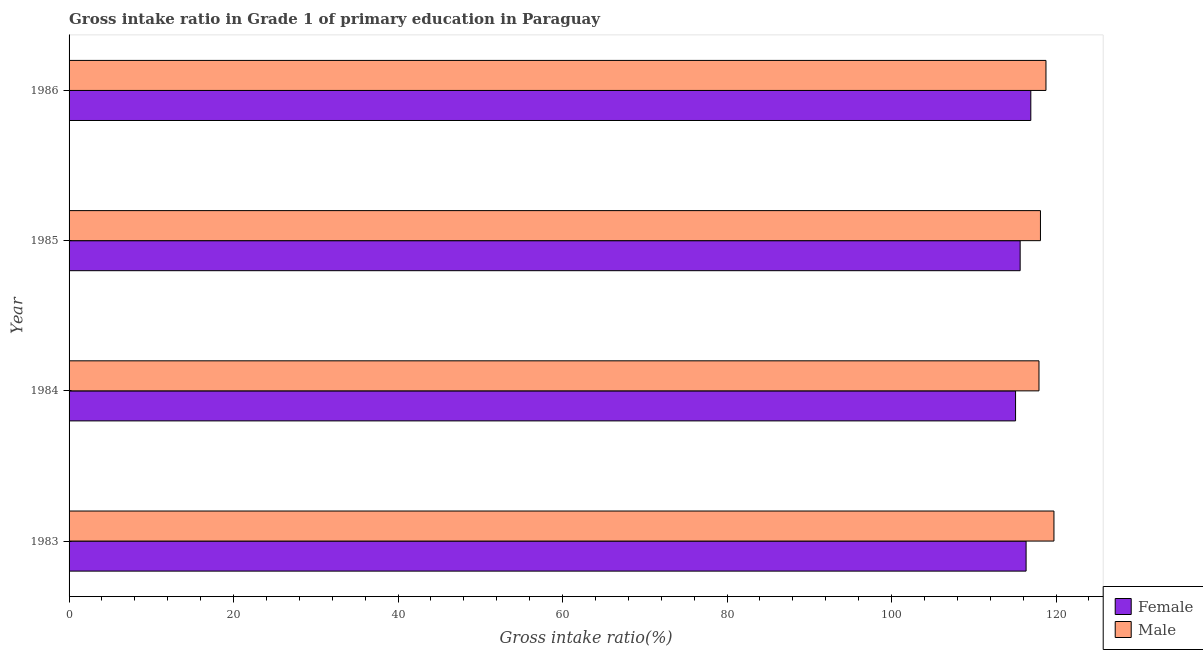How many groups of bars are there?
Provide a succinct answer. 4. Are the number of bars per tick equal to the number of legend labels?
Provide a short and direct response. Yes. How many bars are there on the 4th tick from the top?
Your answer should be very brief. 2. How many bars are there on the 1st tick from the bottom?
Your answer should be very brief. 2. What is the label of the 2nd group of bars from the top?
Keep it short and to the point. 1985. What is the gross intake ratio(female) in 1983?
Offer a terse response. 116.36. Across all years, what is the maximum gross intake ratio(male)?
Provide a succinct answer. 119.75. Across all years, what is the minimum gross intake ratio(female)?
Your response must be concise. 115.08. In which year was the gross intake ratio(female) maximum?
Keep it short and to the point. 1986. In which year was the gross intake ratio(male) minimum?
Offer a very short reply. 1984. What is the total gross intake ratio(female) in the graph?
Provide a short and direct response. 464.01. What is the difference between the gross intake ratio(male) in 1984 and that in 1985?
Offer a very short reply. -0.18. What is the difference between the gross intake ratio(male) in 1985 and the gross intake ratio(female) in 1983?
Offer a terse response. 1.75. What is the average gross intake ratio(male) per year?
Offer a terse response. 118.64. In the year 1985, what is the difference between the gross intake ratio(male) and gross intake ratio(female)?
Ensure brevity in your answer.  2.47. In how many years, is the gross intake ratio(female) greater than 108 %?
Your response must be concise. 4. Is the gross intake ratio(male) in 1983 less than that in 1986?
Keep it short and to the point. No. What is the difference between the highest and the second highest gross intake ratio(male)?
Keep it short and to the point. 0.97. What is the difference between the highest and the lowest gross intake ratio(female)?
Offer a very short reply. 1.85. Is the sum of the gross intake ratio(male) in 1984 and 1986 greater than the maximum gross intake ratio(female) across all years?
Provide a succinct answer. Yes. What does the 2nd bar from the top in 1986 represents?
Provide a succinct answer. Female. How many bars are there?
Give a very brief answer. 8. Are all the bars in the graph horizontal?
Your answer should be compact. Yes. Does the graph contain any zero values?
Offer a terse response. No. Does the graph contain grids?
Provide a short and direct response. No. How are the legend labels stacked?
Your answer should be compact. Vertical. What is the title of the graph?
Your answer should be very brief. Gross intake ratio in Grade 1 of primary education in Paraguay. What is the label or title of the X-axis?
Keep it short and to the point. Gross intake ratio(%). What is the label or title of the Y-axis?
Ensure brevity in your answer.  Year. What is the Gross intake ratio(%) of Female in 1983?
Keep it short and to the point. 116.36. What is the Gross intake ratio(%) in Male in 1983?
Your answer should be compact. 119.75. What is the Gross intake ratio(%) in Female in 1984?
Offer a very short reply. 115.08. What is the Gross intake ratio(%) of Male in 1984?
Offer a terse response. 117.93. What is the Gross intake ratio(%) of Female in 1985?
Your response must be concise. 115.64. What is the Gross intake ratio(%) of Male in 1985?
Provide a succinct answer. 118.11. What is the Gross intake ratio(%) of Female in 1986?
Make the answer very short. 116.93. What is the Gross intake ratio(%) in Male in 1986?
Provide a short and direct response. 118.78. Across all years, what is the maximum Gross intake ratio(%) of Female?
Make the answer very short. 116.93. Across all years, what is the maximum Gross intake ratio(%) in Male?
Your response must be concise. 119.75. Across all years, what is the minimum Gross intake ratio(%) in Female?
Keep it short and to the point. 115.08. Across all years, what is the minimum Gross intake ratio(%) in Male?
Make the answer very short. 117.93. What is the total Gross intake ratio(%) of Female in the graph?
Your answer should be compact. 464.01. What is the total Gross intake ratio(%) of Male in the graph?
Offer a very short reply. 474.56. What is the difference between the Gross intake ratio(%) of Female in 1983 and that in 1984?
Give a very brief answer. 1.28. What is the difference between the Gross intake ratio(%) in Male in 1983 and that in 1984?
Offer a terse response. 1.82. What is the difference between the Gross intake ratio(%) in Female in 1983 and that in 1985?
Offer a terse response. 0.72. What is the difference between the Gross intake ratio(%) of Male in 1983 and that in 1985?
Provide a succinct answer. 1.64. What is the difference between the Gross intake ratio(%) in Female in 1983 and that in 1986?
Give a very brief answer. -0.57. What is the difference between the Gross intake ratio(%) in Male in 1983 and that in 1986?
Make the answer very short. 0.97. What is the difference between the Gross intake ratio(%) of Female in 1984 and that in 1985?
Provide a succinct answer. -0.56. What is the difference between the Gross intake ratio(%) of Male in 1984 and that in 1985?
Your answer should be compact. -0.18. What is the difference between the Gross intake ratio(%) of Female in 1984 and that in 1986?
Ensure brevity in your answer.  -1.85. What is the difference between the Gross intake ratio(%) of Male in 1984 and that in 1986?
Offer a very short reply. -0.85. What is the difference between the Gross intake ratio(%) in Female in 1985 and that in 1986?
Provide a succinct answer. -1.3. What is the difference between the Gross intake ratio(%) in Male in 1985 and that in 1986?
Offer a very short reply. -0.67. What is the difference between the Gross intake ratio(%) of Female in 1983 and the Gross intake ratio(%) of Male in 1984?
Provide a short and direct response. -1.57. What is the difference between the Gross intake ratio(%) in Female in 1983 and the Gross intake ratio(%) in Male in 1985?
Your answer should be very brief. -1.75. What is the difference between the Gross intake ratio(%) in Female in 1983 and the Gross intake ratio(%) in Male in 1986?
Keep it short and to the point. -2.42. What is the difference between the Gross intake ratio(%) of Female in 1984 and the Gross intake ratio(%) of Male in 1985?
Your answer should be compact. -3.03. What is the difference between the Gross intake ratio(%) of Female in 1984 and the Gross intake ratio(%) of Male in 1986?
Your response must be concise. -3.7. What is the difference between the Gross intake ratio(%) in Female in 1985 and the Gross intake ratio(%) in Male in 1986?
Keep it short and to the point. -3.14. What is the average Gross intake ratio(%) in Female per year?
Keep it short and to the point. 116. What is the average Gross intake ratio(%) in Male per year?
Offer a very short reply. 118.64. In the year 1983, what is the difference between the Gross intake ratio(%) in Female and Gross intake ratio(%) in Male?
Provide a succinct answer. -3.39. In the year 1984, what is the difference between the Gross intake ratio(%) of Female and Gross intake ratio(%) of Male?
Provide a short and direct response. -2.85. In the year 1985, what is the difference between the Gross intake ratio(%) in Female and Gross intake ratio(%) in Male?
Your answer should be very brief. -2.47. In the year 1986, what is the difference between the Gross intake ratio(%) in Female and Gross intake ratio(%) in Male?
Provide a short and direct response. -1.84. What is the ratio of the Gross intake ratio(%) of Female in 1983 to that in 1984?
Give a very brief answer. 1.01. What is the ratio of the Gross intake ratio(%) in Male in 1983 to that in 1984?
Keep it short and to the point. 1.02. What is the ratio of the Gross intake ratio(%) of Female in 1983 to that in 1985?
Your answer should be very brief. 1.01. What is the ratio of the Gross intake ratio(%) in Male in 1983 to that in 1985?
Offer a terse response. 1.01. What is the ratio of the Gross intake ratio(%) of Female in 1983 to that in 1986?
Offer a terse response. 1. What is the ratio of the Gross intake ratio(%) of Male in 1983 to that in 1986?
Give a very brief answer. 1.01. What is the ratio of the Gross intake ratio(%) in Female in 1984 to that in 1986?
Give a very brief answer. 0.98. What is the ratio of the Gross intake ratio(%) in Male in 1984 to that in 1986?
Your answer should be compact. 0.99. What is the ratio of the Gross intake ratio(%) in Female in 1985 to that in 1986?
Keep it short and to the point. 0.99. What is the difference between the highest and the second highest Gross intake ratio(%) of Female?
Your answer should be compact. 0.57. What is the difference between the highest and the second highest Gross intake ratio(%) of Male?
Your response must be concise. 0.97. What is the difference between the highest and the lowest Gross intake ratio(%) in Female?
Offer a very short reply. 1.85. What is the difference between the highest and the lowest Gross intake ratio(%) of Male?
Provide a succinct answer. 1.82. 